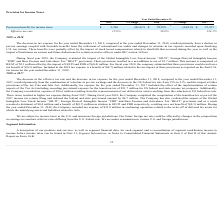Looking at Netgear's financial data, please calculate: What was the change in the US federal tax rate from 2017 to 2018? Based on the calculation: 21% - 35% , the result is -14 (percentage). This is based on the information: "ncome taxes $ 3,780 (85.4)% $ 25,878 (54.9)% $ 57,357 ncome taxes $ 3,780 (85.4)% $ 25,878 (54.9)% $ 57,357 e decrease in the US federal tax rate from 35% to 21%, and the impact of other provisions of..." The key data points involved are: 21, 35. Also, What accounted for the decrease in tax expense in 2019? A decline in pre-tax earnings coupled with favorable benefits from the settlement of international tax audits and changes in estimate in tax expense recorded upon finalizing U.S. tax returns.. The document states: "r ended December 31, 2018, resulted primarily from a decline in pre-tax earnings coupled with favorable benefits from the settlement of international ..." Also, can you calculate: What was the change in effective tax rate from 2018 to 2019? Based on the calculation: 12.8% - 59.9% , the result is -47.1 (percentage). This is based on the information: "Effective tax rate 12.8% 59.9% 124.1% Effective tax rate 12.8% 59.9% 124.1%..." The key data points involved are: 12.8, 59.9. Additionally, Which year has the highest provision (benefit) for income taxes? According to the financial document, 2017. The relevant text states: "2019 % Change 2018 % Change 2017..." Also, What resulted in a net addition to tax in 2019? Global Intangible Low-Taxed Income “GILTI”, Foreign Derived Intangible Income “FDII” and Base Erosion and Anti-abuse Tax “BEAT” provisions. The document states: "The Company has also evaluated the impact of the Global Intangible Low-Taxed Income “GILTI”, Foreign Derived Intangible Income “FDII” and Base Erosion..." Also, What could affect the future foreign tax rate? Changes in the composition in earnings in countries with tax rates differing from the U.S. federal rate.. The document states: ". Our future foreign tax rate could be affected by changes in the composition in earnings in countries with tax rates differing from the U.S. federal ..." 